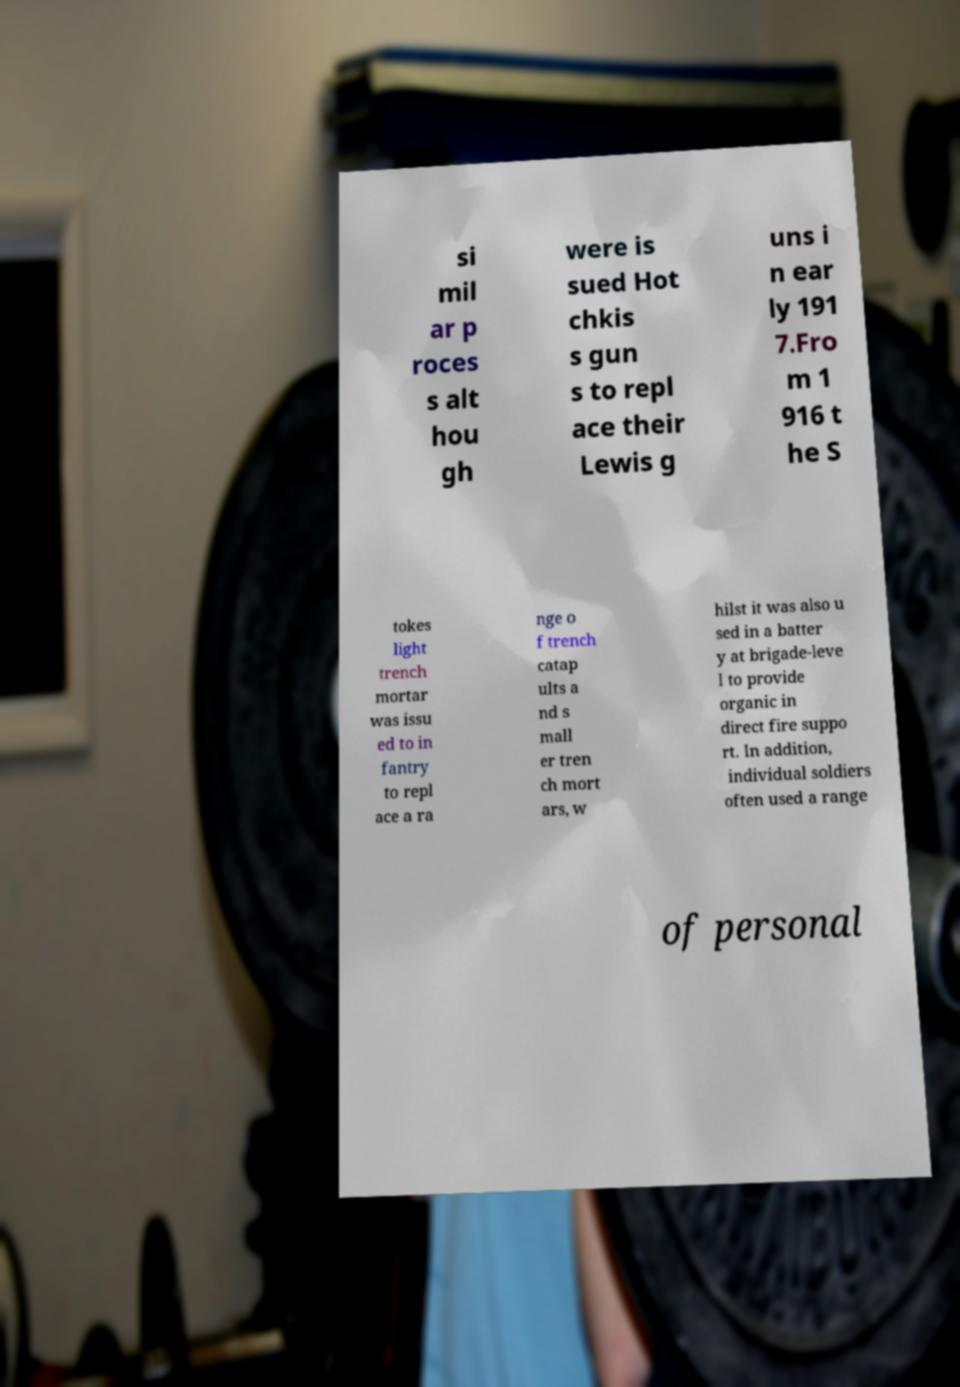What messages or text are displayed in this image? I need them in a readable, typed format. si mil ar p roces s alt hou gh were is sued Hot chkis s gun s to repl ace their Lewis g uns i n ear ly 191 7.Fro m 1 916 t he S tokes light trench mortar was issu ed to in fantry to repl ace a ra nge o f trench catap ults a nd s mall er tren ch mort ars, w hilst it was also u sed in a batter y at brigade-leve l to provide organic in direct fire suppo rt. In addition, individual soldiers often used a range of personal 